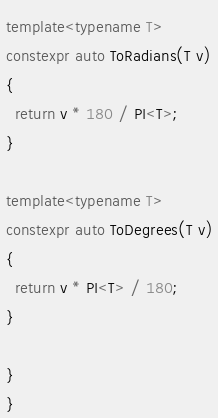<code> <loc_0><loc_0><loc_500><loc_500><_C++_>template<typename T>
constexpr auto ToRadians(T v)
{
  return v * 180 / PI<T>;
}

template<typename T>
constexpr auto ToDegrees(T v)
{
  return v * PI<T> / 180;
}

}
}
</code> 